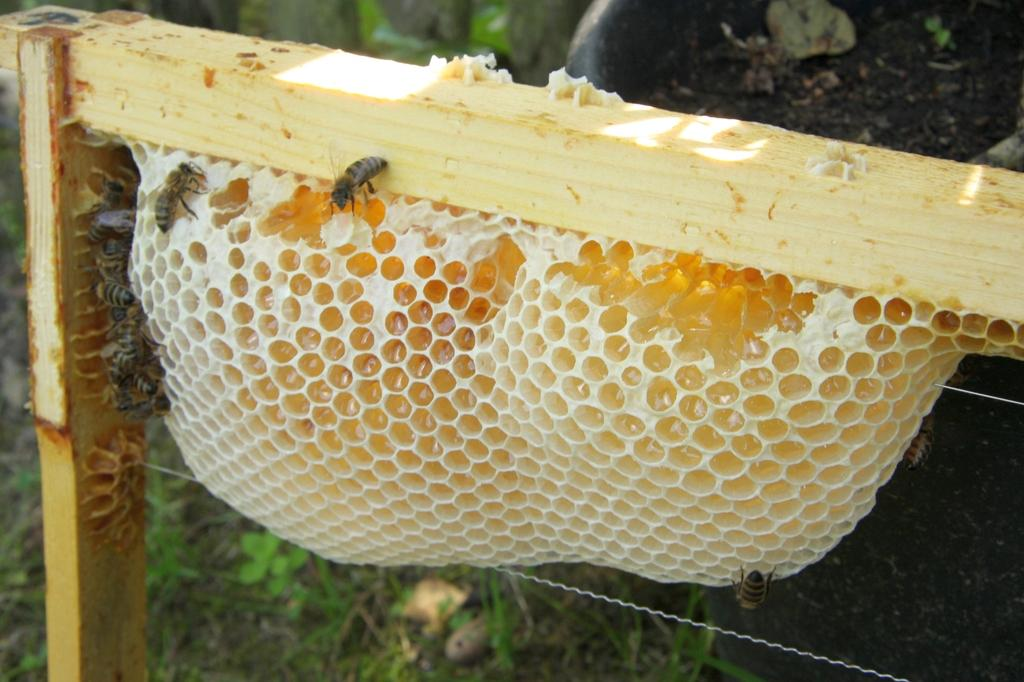What is the main subject of the image? The main subject of the image is a honeycomb. Is the honeycomb connected to anything? Yes, the honeycomb is attached to a wooden object. Are there any other living creatures visible in the image? Yes, there are honey bees on the left side of the image. Can you see a hen weaving a thread in the image? No, there is no hen or thread present in the image. What type of rat can be seen interacting with the honeycomb in the image? There is no rat present in the image; it features a honeycomb and honey bees. 